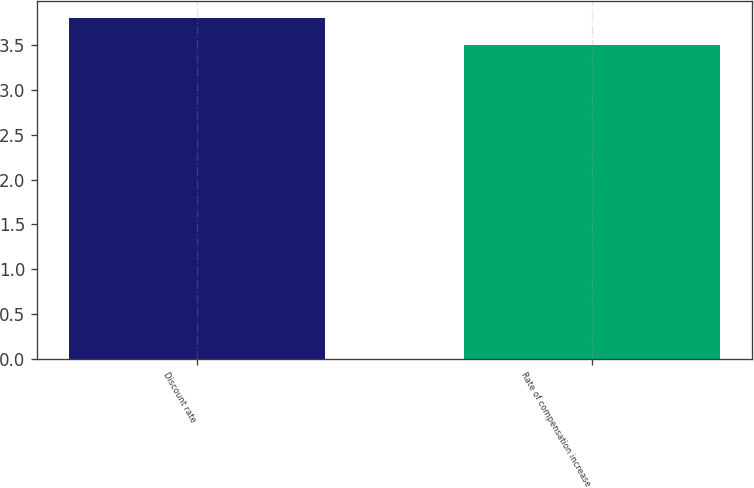Convert chart to OTSL. <chart><loc_0><loc_0><loc_500><loc_500><bar_chart><fcel>Discount rate<fcel>Rate of compensation increase<nl><fcel>3.8<fcel>3.5<nl></chart> 